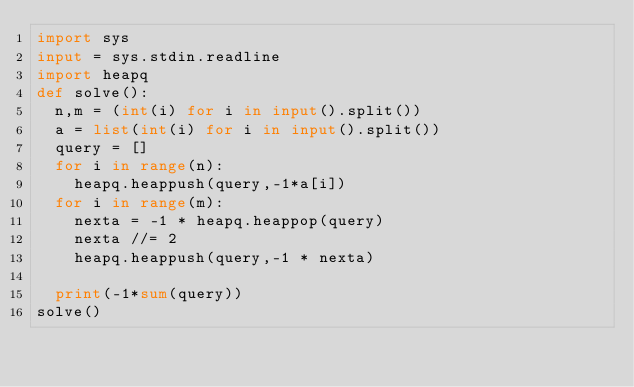<code> <loc_0><loc_0><loc_500><loc_500><_Python_>import sys
input = sys.stdin.readline
import heapq
def solve():
  n,m = (int(i) for i in input().split())
  a = list(int(i) for i in input().split())
  query = []
  for i in range(n):
    heapq.heappush(query,-1*a[i])
  for i in range(m):
    nexta = -1 * heapq.heappop(query)
    nexta //= 2
    heapq.heappush(query,-1 * nexta)

  print(-1*sum(query))
solve()</code> 